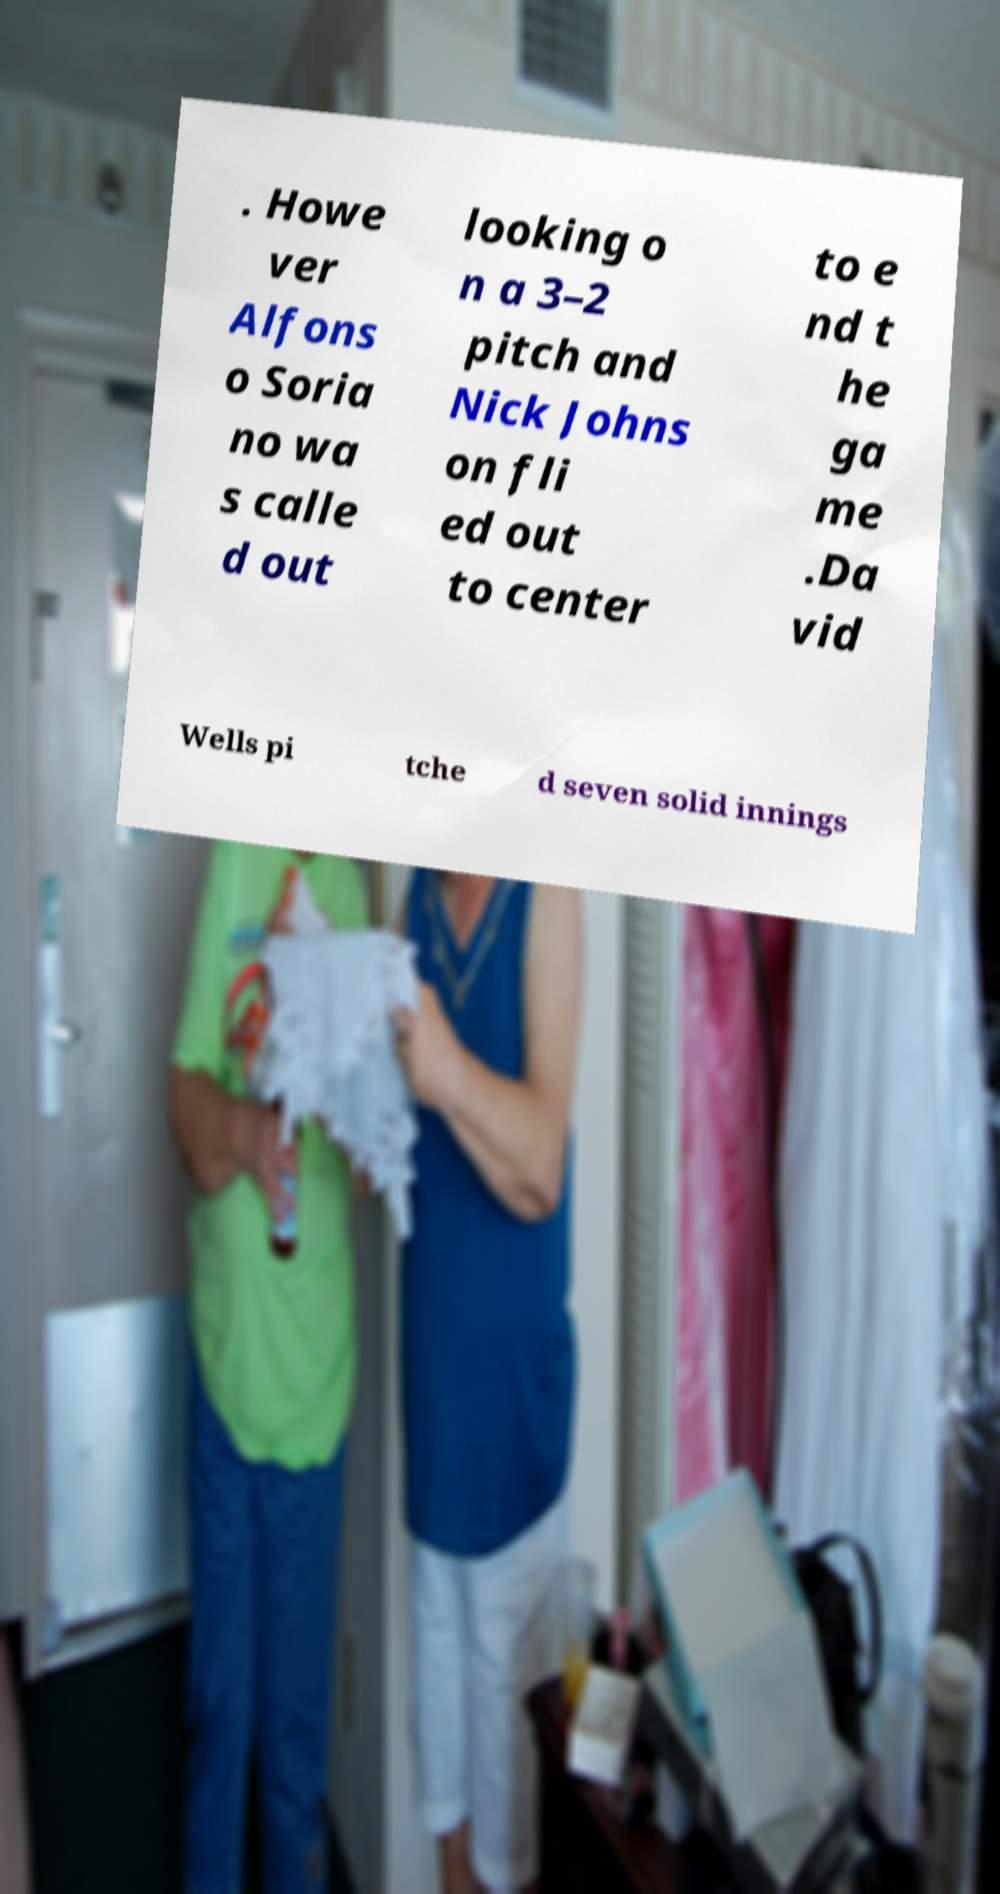What messages or text are displayed in this image? I need them in a readable, typed format. . Howe ver Alfons o Soria no wa s calle d out looking o n a 3–2 pitch and Nick Johns on fli ed out to center to e nd t he ga me .Da vid Wells pi tche d seven solid innings 